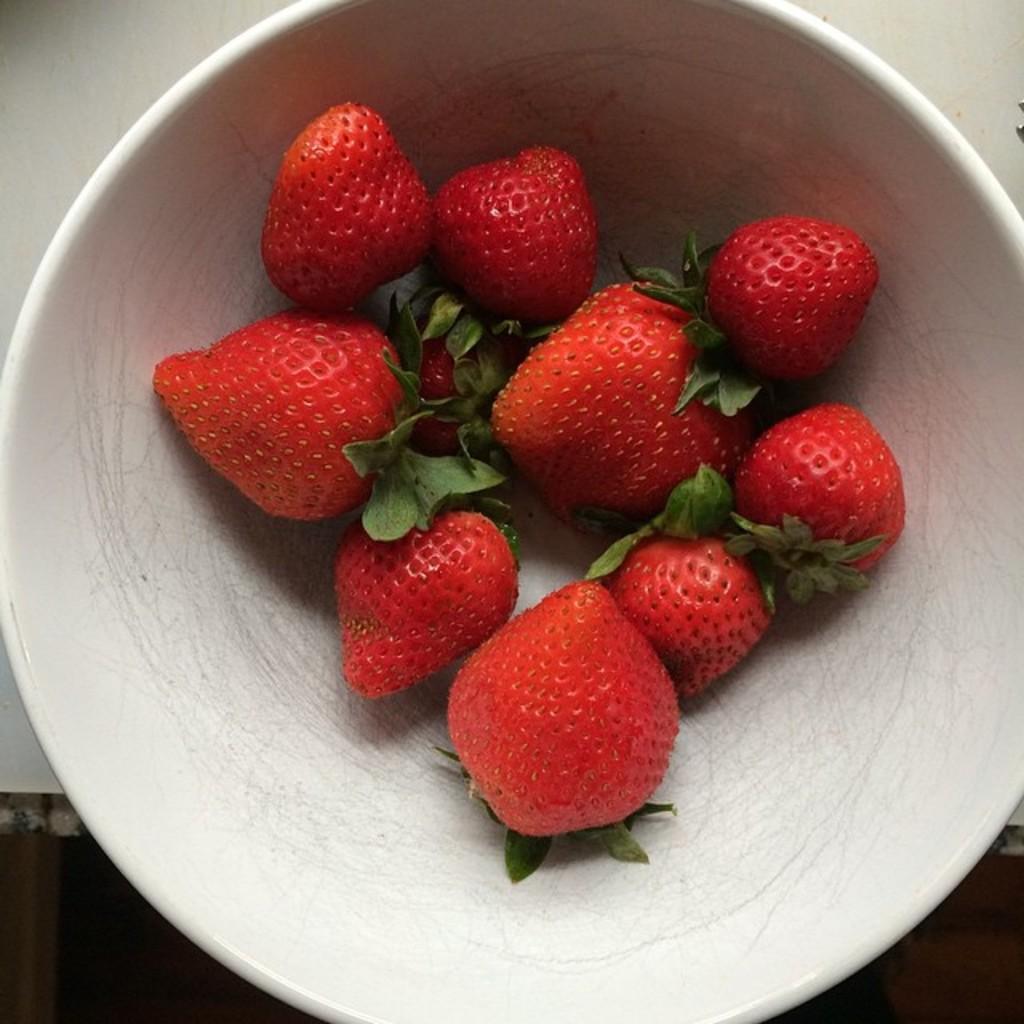Can you describe this image briefly? In this picture, there is a bowl placed on the table. In the bowl, there are strawberries. 